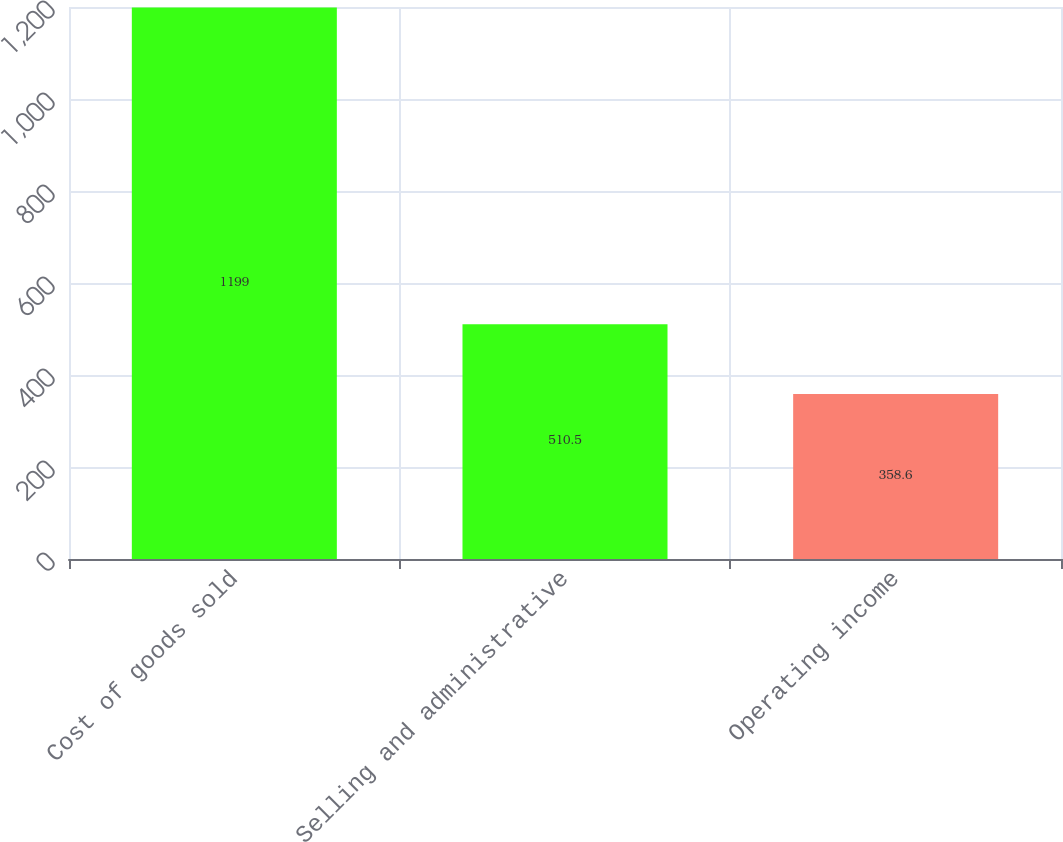Convert chart to OTSL. <chart><loc_0><loc_0><loc_500><loc_500><bar_chart><fcel>Cost of goods sold<fcel>Selling and administrative<fcel>Operating income<nl><fcel>1199<fcel>510.5<fcel>358.6<nl></chart> 